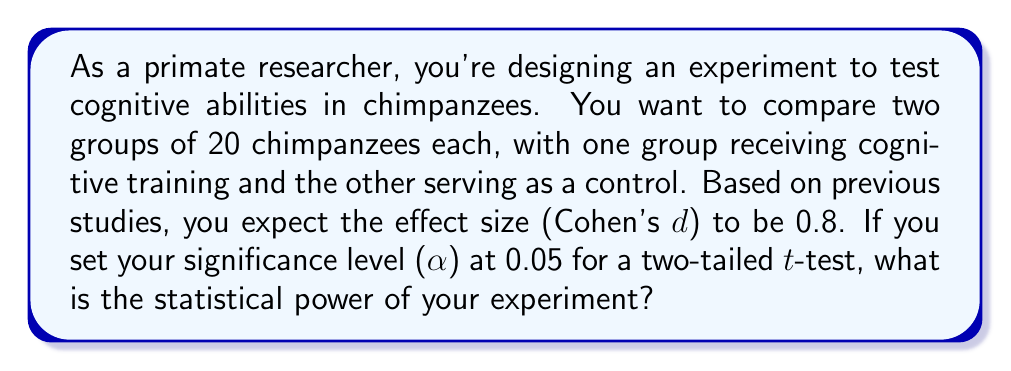Provide a solution to this math problem. To calculate the statistical power for this experiment, we'll follow these steps:

1. Identify the given information:
   - Sample size per group (n) = 20
   - Effect size (Cohen's d) = 0.8
   - Significance level (α) = 0.05
   - Two-tailed test

2. Calculate the degrees of freedom (df):
   $df = n_1 + n_2 - 2 = 20 + 20 - 2 = 38$

3. Determine the critical t-value for α = 0.05 and df = 38:
   Using a t-distribution table or calculator, we find:
   $t_{critical} = 2.024$

4. Calculate the non-centrality parameter (δ):
   $\delta = d \sqrt{\frac{n}{2}} = 0.8 \sqrt{\frac{20}{2}} = 0.8 \sqrt{10} = 2.53$

5. Calculate the probability of Type II error (β):
   Using a non-central t-distribution calculator with df = 38, δ = 2.53, and t_critical = 2.024, we find:
   $\beta = 0.1998$

6. Calculate the statistical power:
   $Power = 1 - \beta = 1 - 0.1998 = 0.8002$

Therefore, the statistical power of your experiment is approximately 0.8002 or 80.02%.
Answer: The statistical power of the experiment is 0.8002 (or 80.02%). 